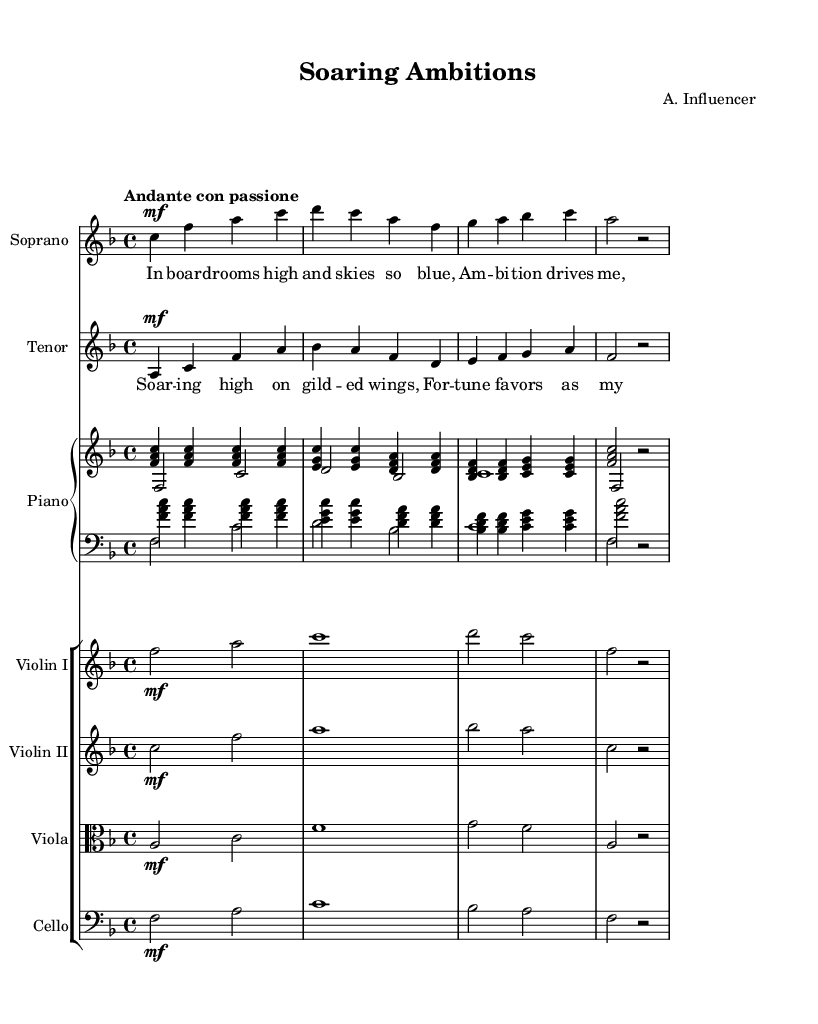What is the key signature of this music? The key signature is F major, which has one flat (B flat). You can confirm this by examining the key signature noted at the beginning of the music, right after the clef symbol.
Answer: F major What is the time signature of the piece? The time signature is 4/4, indicating four beats per measure, which can be seen immediately following the key signature in the score.
Answer: 4/4 What is the tempo marking for the piece? The tempo marking is "Andante con passione," which suggests a moderately slow tempo with passion. It’s indicated at the beginning of the score and illustrates the performance style intended for the piece.
Answer: Andante con passione How many measures are in the soprano part? The soprano part consists of 4 measures as determined by counting the vertical bar lines that separate the music into measures.
Answer: 4 What instruments are involved in this opera piece? The instruments include Soprano, Tenor, Piano, Violin I, Violin II, Viola, and Cello. This can be found at the beginning of each staff, designating the instruments used in the score.
Answer: Soprano, Tenor, Piano, Violin I, Violin II, Viola, Cello What is the main theme expressed in the lyrics of the tenor part? The main theme expressed in the tenor part reflects aspiration and fortune, encapsulated within the lyrics about soaring high and being favored by fortune. This can be interpreted by analyzing the lines provided in the tenor’s lyrics.
Answer: Aspiration and fortune What type of opera does this piece belong to? This piece belongs to the Romantic opera genre, characterized by its emotional expression and focus on individual characters' ambitions and desires, clearly aligning with the quest for love and success. This is evident in the thematic focus of the lyrics and overall composition.
Answer: Romantic opera 